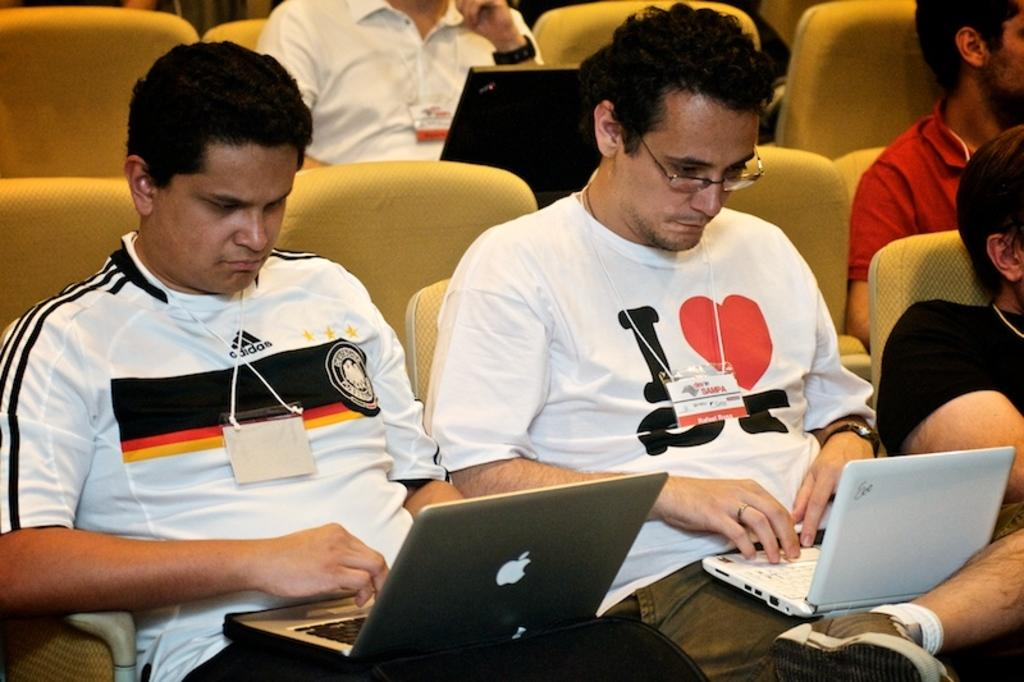What is happening in the image involving a group of people? There is a group of people in the image, and they are sitting on chairs. What are the people holding or using while sitting on the chairs? The people have laptops on their laps. Can you describe the setting in which the people are sitting? There are additional chairs visible in the background, suggesting a larger gathering or meeting space. How many people are jumping in the image? There are no people jumping in the image; they are all sitting on chairs. What type of grip does the chair have on the floor? The chairs in the image do not have a specific grip mentioned, but they appear to be stable on the floor. 